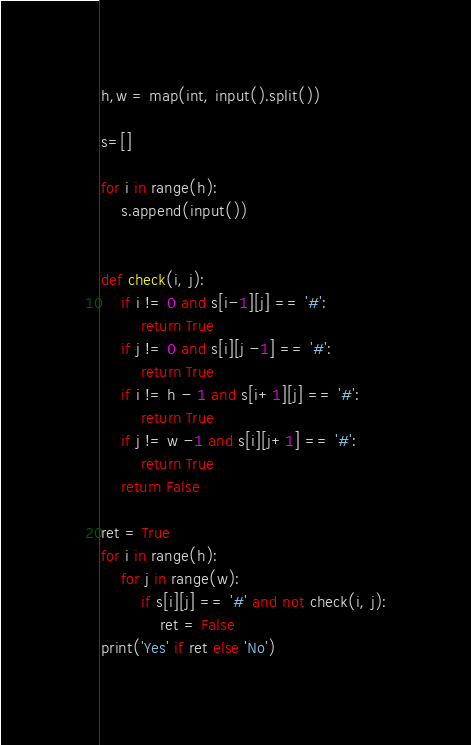<code> <loc_0><loc_0><loc_500><loc_500><_Python_>h,w = map(int, input().split())

s=[]

for i in range(h):
    s.append(input())


def check(i, j):
    if i != 0 and s[i-1][j] == '#':
        return True
    if j != 0 and s[i][j -1] == '#':
        return True
    if i != h - 1 and s[i+1][j] == '#':
        return True
    if j != w -1 and s[i][j+1] == '#':
        return True
    return False

ret = True
for i in range(h):
    for j in range(w):
        if s[i][j] == '#' and not check(i, j):
            ret = False
print('Yes' if ret else 'No')</code> 